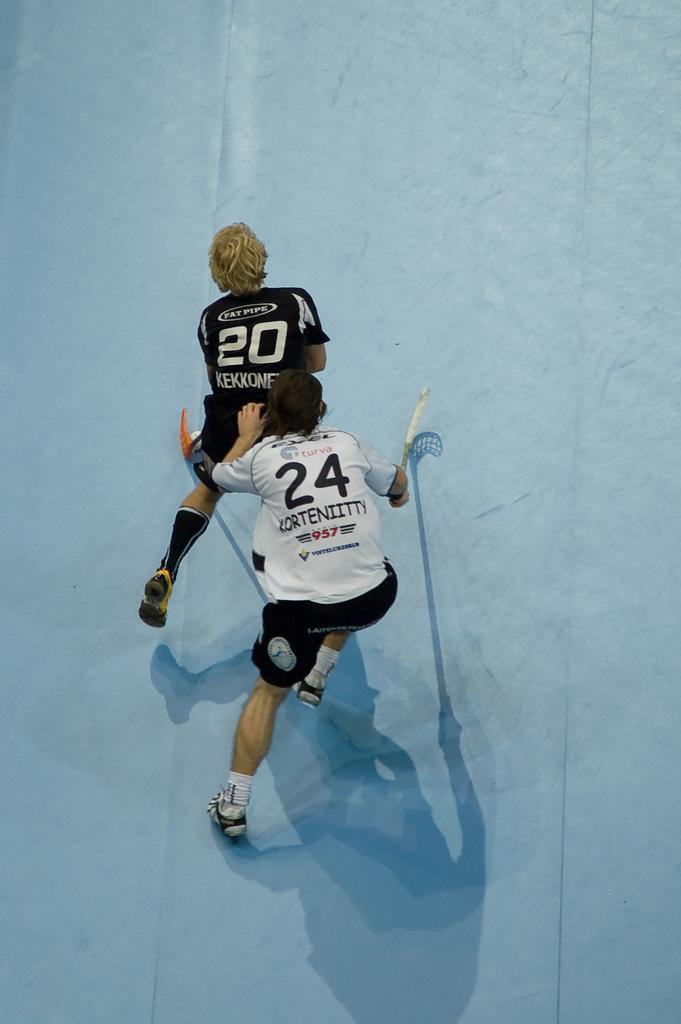Provide a one-sentence caption for the provided image. Two hockey players standing behind one another, 20 in front 24 in back. 